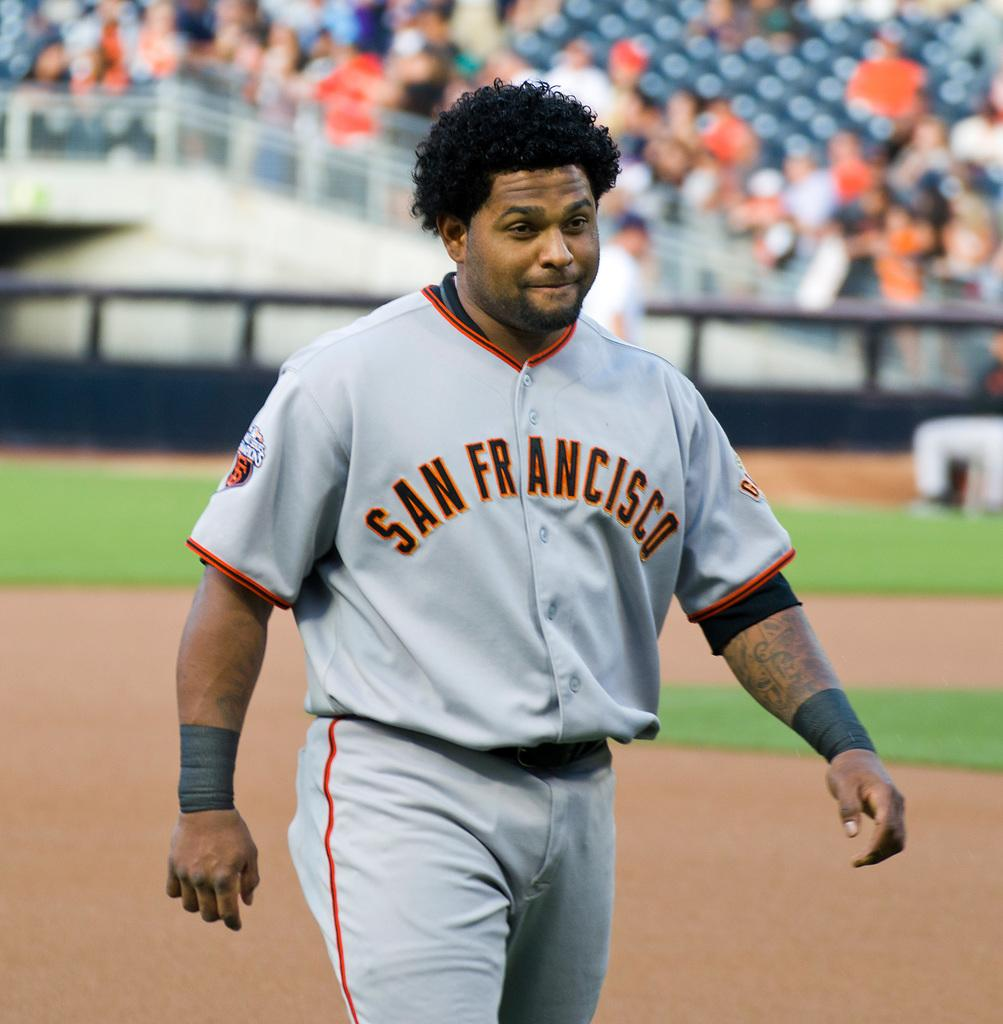<image>
Describe the image concisely. a man in a san francisco jersey on the field 